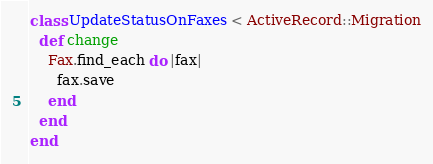<code> <loc_0><loc_0><loc_500><loc_500><_Ruby_>class UpdateStatusOnFaxes < ActiveRecord::Migration
  def change
    Fax.find_each do |fax|
      fax.save
    end
  end
end
</code> 